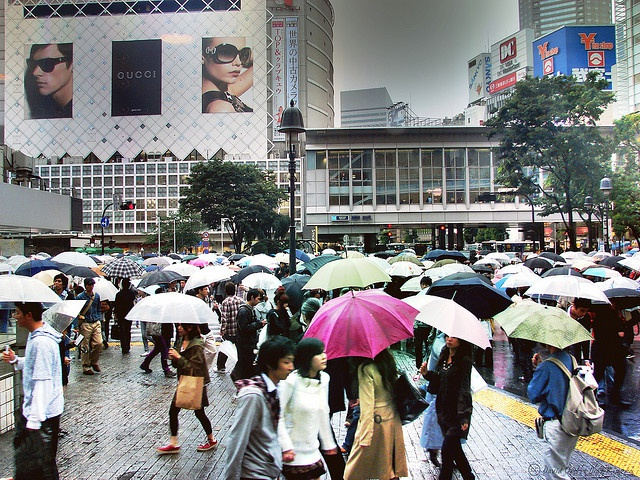Describe the objects in this image and their specific colors. I can see umbrella in gray, black, white, and darkgray tones, people in gray, black, darkgray, and lightgray tones, people in gray, black, white, lightblue, and maroon tones, people in gray, black, darkgray, and lightgray tones, and people in gray, white, black, beige, and darkgray tones in this image. 